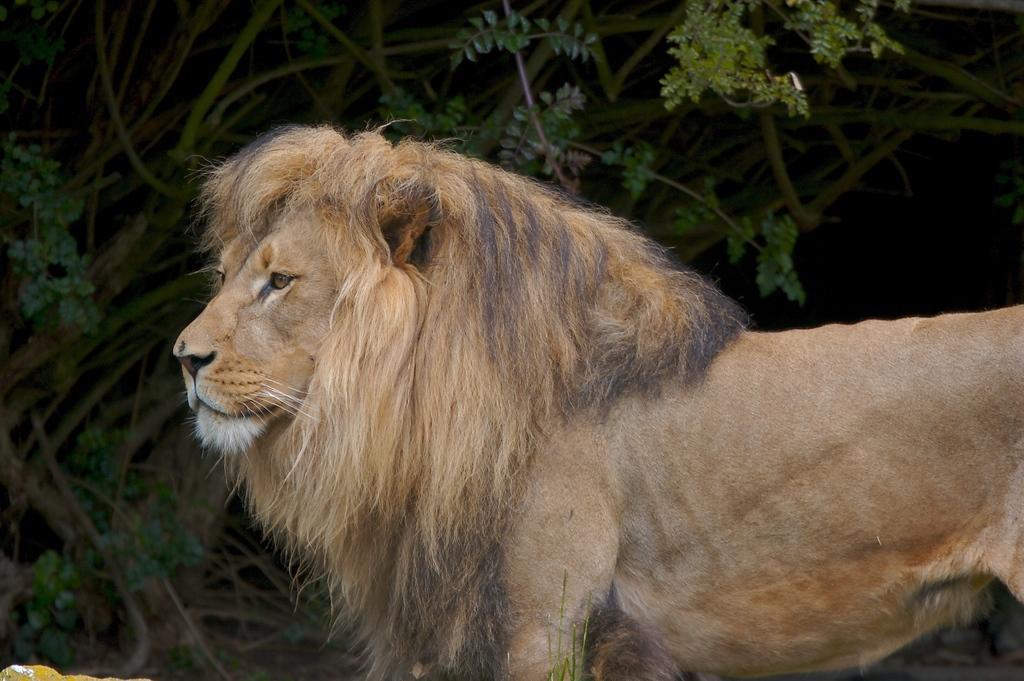Can you describe this image briefly? Here I can see a lion facing towards the left side. In the background there are some plants. 